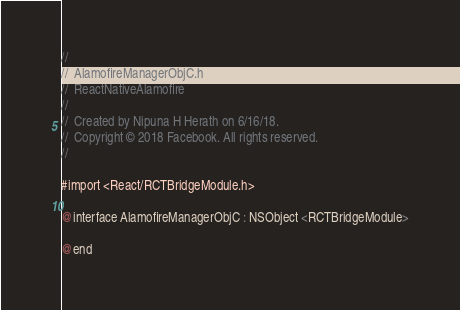Convert code to text. <code><loc_0><loc_0><loc_500><loc_500><_C_>//
//  AlamofireManagerObjC.h
//  ReactNativeAlamofire
//
//  Created by Nipuna H Herath on 6/16/18.
//  Copyright © 2018 Facebook. All rights reserved.
//

#import <React/RCTBridgeModule.h>

@interface AlamofireManagerObjC : NSObject <RCTBridgeModule>

@end
</code> 